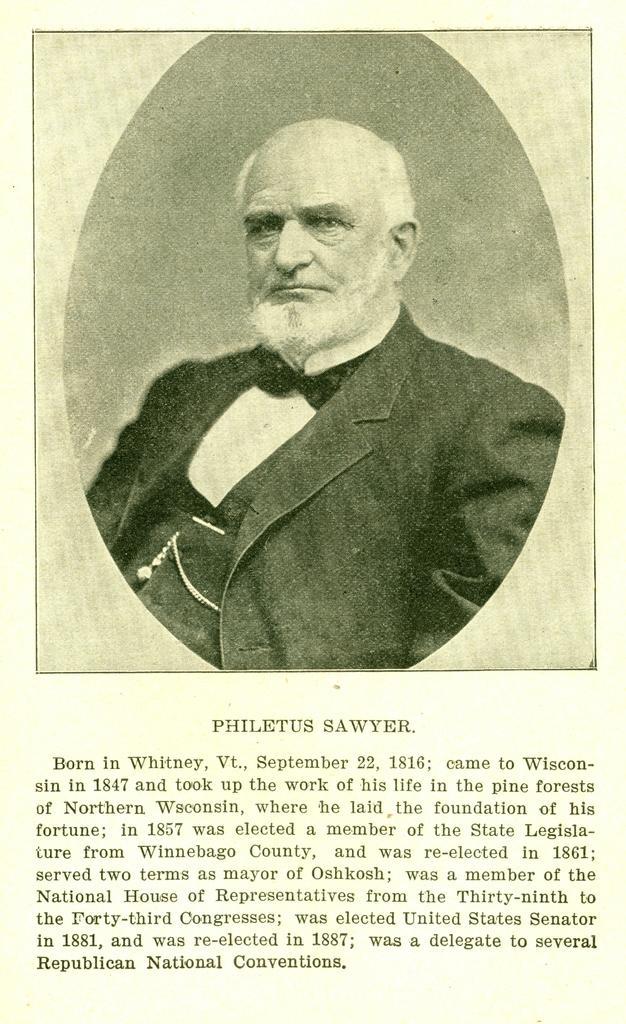Please provide a concise description of this image. This is a picture of a poster. In this picture we can see a woman wearing a blazer. At the bottom portion of the picture we can see some information. 